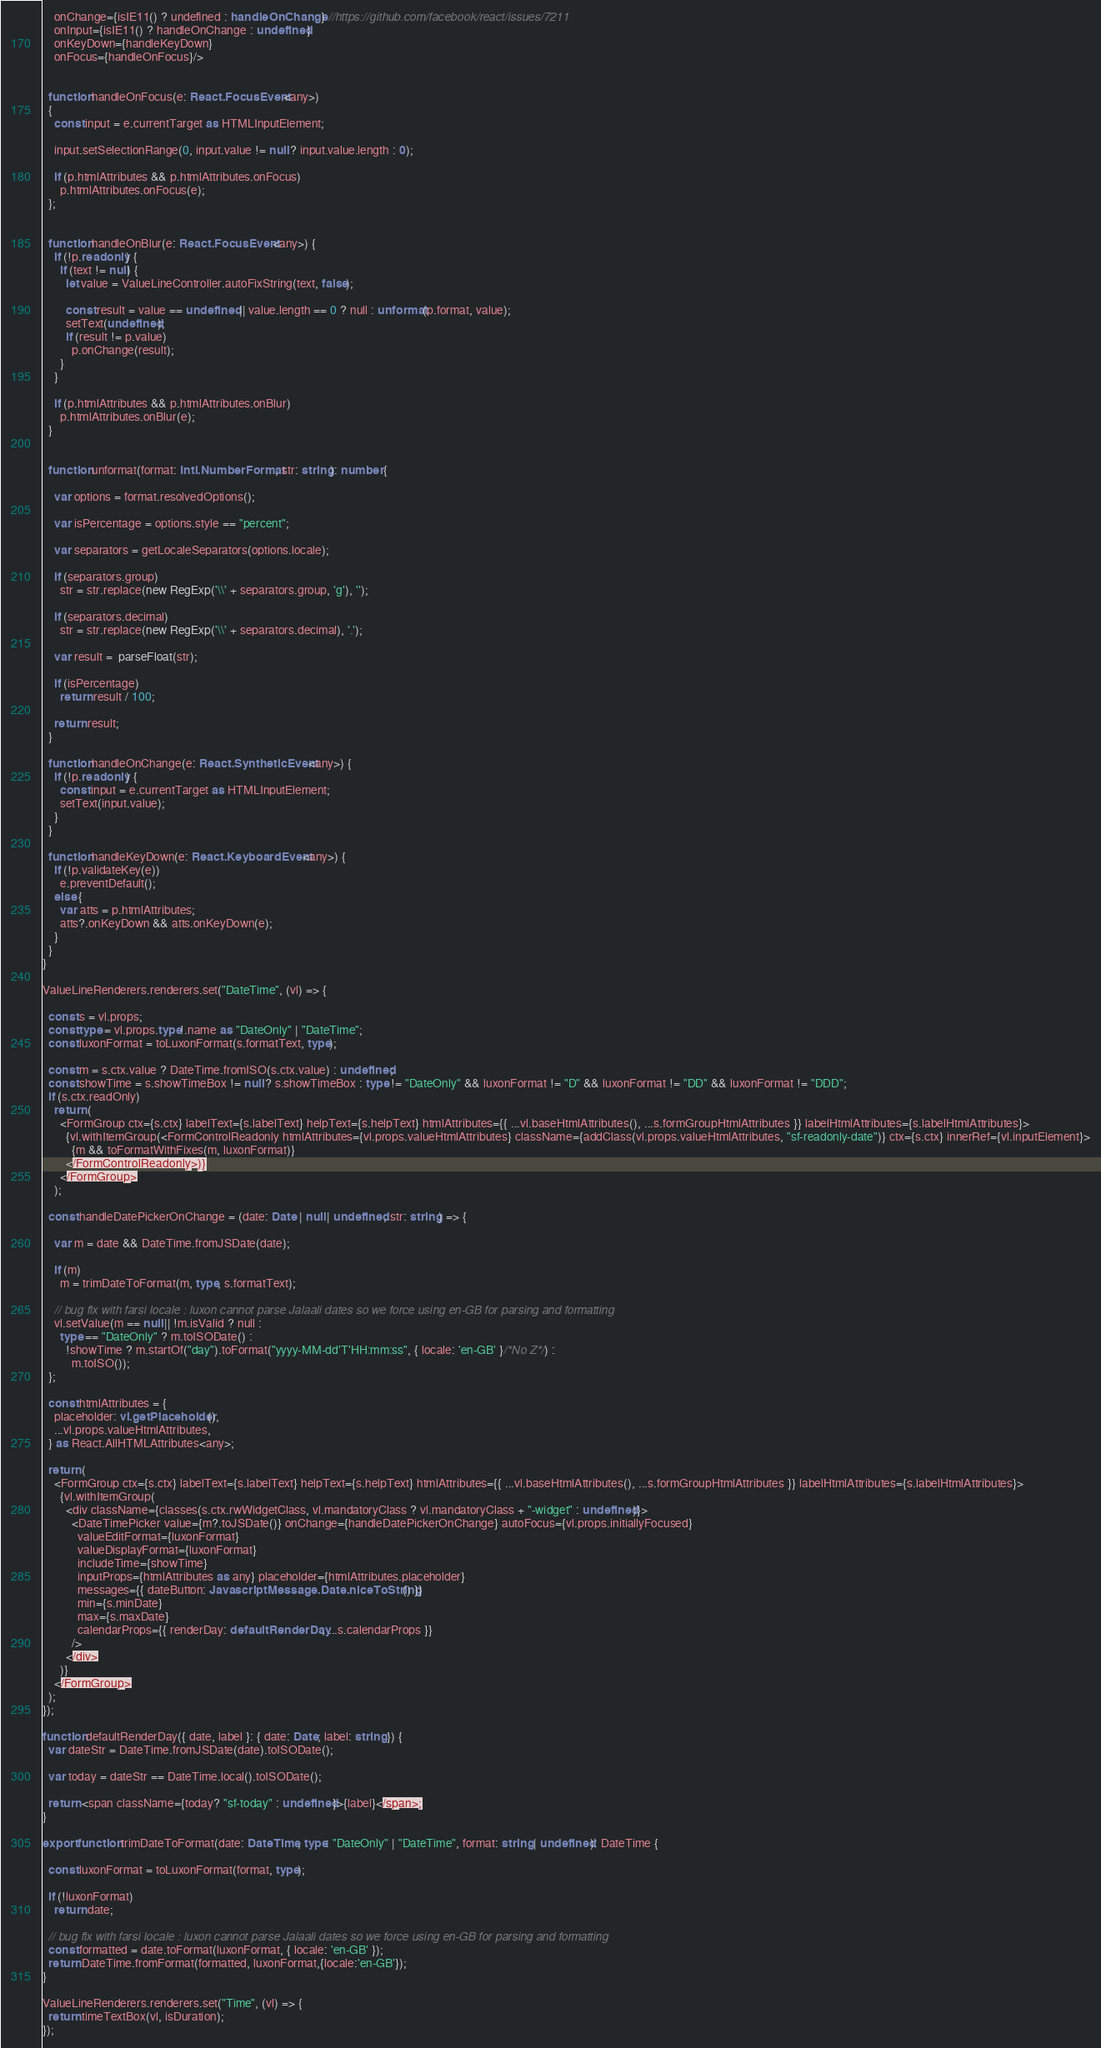Convert code to text. <code><loc_0><loc_0><loc_500><loc_500><_TypeScript_>    onChange={isIE11() ? undefined : handleOnChange} //https://github.com/facebook/react/issues/7211
    onInput={isIE11() ? handleOnChange : undefined}
    onKeyDown={handleKeyDown}
    onFocus={handleOnFocus}/>


  function handleOnFocus(e: React.FocusEvent<any>)
  {
    const input = e.currentTarget as HTMLInputElement;

    input.setSelectionRange(0, input.value != null ? input.value.length : 0);

    if (p.htmlAttributes && p.htmlAttributes.onFocus)
      p.htmlAttributes.onFocus(e);
  };


  function handleOnBlur(e: React.FocusEvent<any>) {
    if (!p.readonly) {
      if (text != null) {
        let value = ValueLineController.autoFixString(text, false);

        const result = value == undefined || value.length == 0 ? null : unformat(p.format, value);
        setText(undefined);
        if (result != p.value)
          p.onChange(result);
      }
    }

    if (p.htmlAttributes && p.htmlAttributes.onBlur)
      p.htmlAttributes.onBlur(e);
  }

 
  function unformat(format: Intl.NumberFormat, str: string): number {

    var options = format.resolvedOptions();

    var isPercentage = options.style == "percent";

    var separators = getLocaleSeparators(options.locale);

    if (separators.group)
      str = str.replace(new RegExp('\\' + separators.group, 'g'), '');

    if (separators.decimal)
      str = str.replace(new RegExp('\\' + separators.decimal), '.');

    var result =  parseFloat(str);

    if (isPercentage)
      return result / 100;

    return result;
  }

  function handleOnChange(e: React.SyntheticEvent<any>) {
    if (!p.readonly) {
      const input = e.currentTarget as HTMLInputElement;
      setText(input.value);
    }
  }

  function handleKeyDown(e: React.KeyboardEvent<any>) {
    if (!p.validateKey(e))
      e.preventDefault();
    else {
      var atts = p.htmlAttributes;
      atts?.onKeyDown && atts.onKeyDown(e);
    }
  }
}

ValueLineRenderers.renderers.set("DateTime", (vl) => {

  const s = vl.props;
  const type = vl.props.type!.name as "DateOnly" | "DateTime";
  const luxonFormat = toLuxonFormat(s.formatText, type);

  const m = s.ctx.value ? DateTime.fromISO(s.ctx.value) : undefined;
  const showTime = s.showTimeBox != null ? s.showTimeBox : type != "DateOnly" && luxonFormat != "D" && luxonFormat != "DD" && luxonFormat != "DDD";
  if (s.ctx.readOnly)
    return (
      <FormGroup ctx={s.ctx} labelText={s.labelText} helpText={s.helpText} htmlAttributes={{ ...vl.baseHtmlAttributes(), ...s.formGroupHtmlAttributes }} labelHtmlAttributes={s.labelHtmlAttributes}>
        {vl.withItemGroup(<FormControlReadonly htmlAttributes={vl.props.valueHtmlAttributes} className={addClass(vl.props.valueHtmlAttributes, "sf-readonly-date")} ctx={s.ctx} innerRef={vl.inputElement}>
          {m && toFormatWithFixes(m, luxonFormat)}
        </FormControlReadonly>)}
      </FormGroup>
    );

  const handleDatePickerOnChange = (date: Date | null | undefined, str: string) => {

    var m = date && DateTime.fromJSDate(date);

    if (m)
      m = trimDateToFormat(m, type, s.formatText);

    // bug fix with farsi locale : luxon cannot parse Jalaali dates so we force using en-GB for parsing and formatting
    vl.setValue(m == null || !m.isValid ? null :
      type == "DateOnly" ? m.toISODate() :
        !showTime ? m.startOf("day").toFormat("yyyy-MM-dd'T'HH:mm:ss", { locale: 'en-GB' }/*No Z*/) :
          m.toISO());
  };

  const htmlAttributes = {
    placeholder: vl.getPlaceholder(),
    ...vl.props.valueHtmlAttributes,
  } as React.AllHTMLAttributes<any>;

  return (
    <FormGroup ctx={s.ctx} labelText={s.labelText} helpText={s.helpText} htmlAttributes={{ ...vl.baseHtmlAttributes(), ...s.formGroupHtmlAttributes }} labelHtmlAttributes={s.labelHtmlAttributes}>
      {vl.withItemGroup(
        <div className={classes(s.ctx.rwWidgetClass, vl.mandatoryClass ? vl.mandatoryClass + "-widget" : undefined)}>
          <DateTimePicker value={m?.toJSDate()} onChange={handleDatePickerOnChange} autoFocus={vl.props.initiallyFocused}
            valueEditFormat={luxonFormat}
            valueDisplayFormat={luxonFormat}
            includeTime={showTime}
            inputProps={htmlAttributes as any} placeholder={htmlAttributes.placeholder}
            messages={{ dateButton: JavascriptMessage.Date.niceToString() }}
            min={s.minDate}
            max={s.maxDate}
            calendarProps={{ renderDay: defaultRenderDay, ...s.calendarProps }}
          />
        </div>
      )}
    </FormGroup>
  );
});

function defaultRenderDay({ date, label }: { date: Date; label: string }) {
  var dateStr = DateTime.fromJSDate(date).toISODate();

  var today = dateStr == DateTime.local().toISODate();

  return <span className={today? "sf-today" : undefined}>{label}</span>;
}

export function trimDateToFormat(date: DateTime, type: "DateOnly" | "DateTime", format: string | undefined): DateTime {

  const luxonFormat = toLuxonFormat(format, type);

  if (!luxonFormat)
    return date; 

  // bug fix with farsi locale : luxon cannot parse Jalaali dates so we force using en-GB for parsing and formatting
  const formatted = date.toFormat(luxonFormat, { locale: 'en-GB' });
  return DateTime.fromFormat(formatted, luxonFormat,{locale:'en-GB'}); 
}

ValueLineRenderers.renderers.set("Time", (vl) => {
  return timeTextBox(vl, isDuration);
});
</code> 